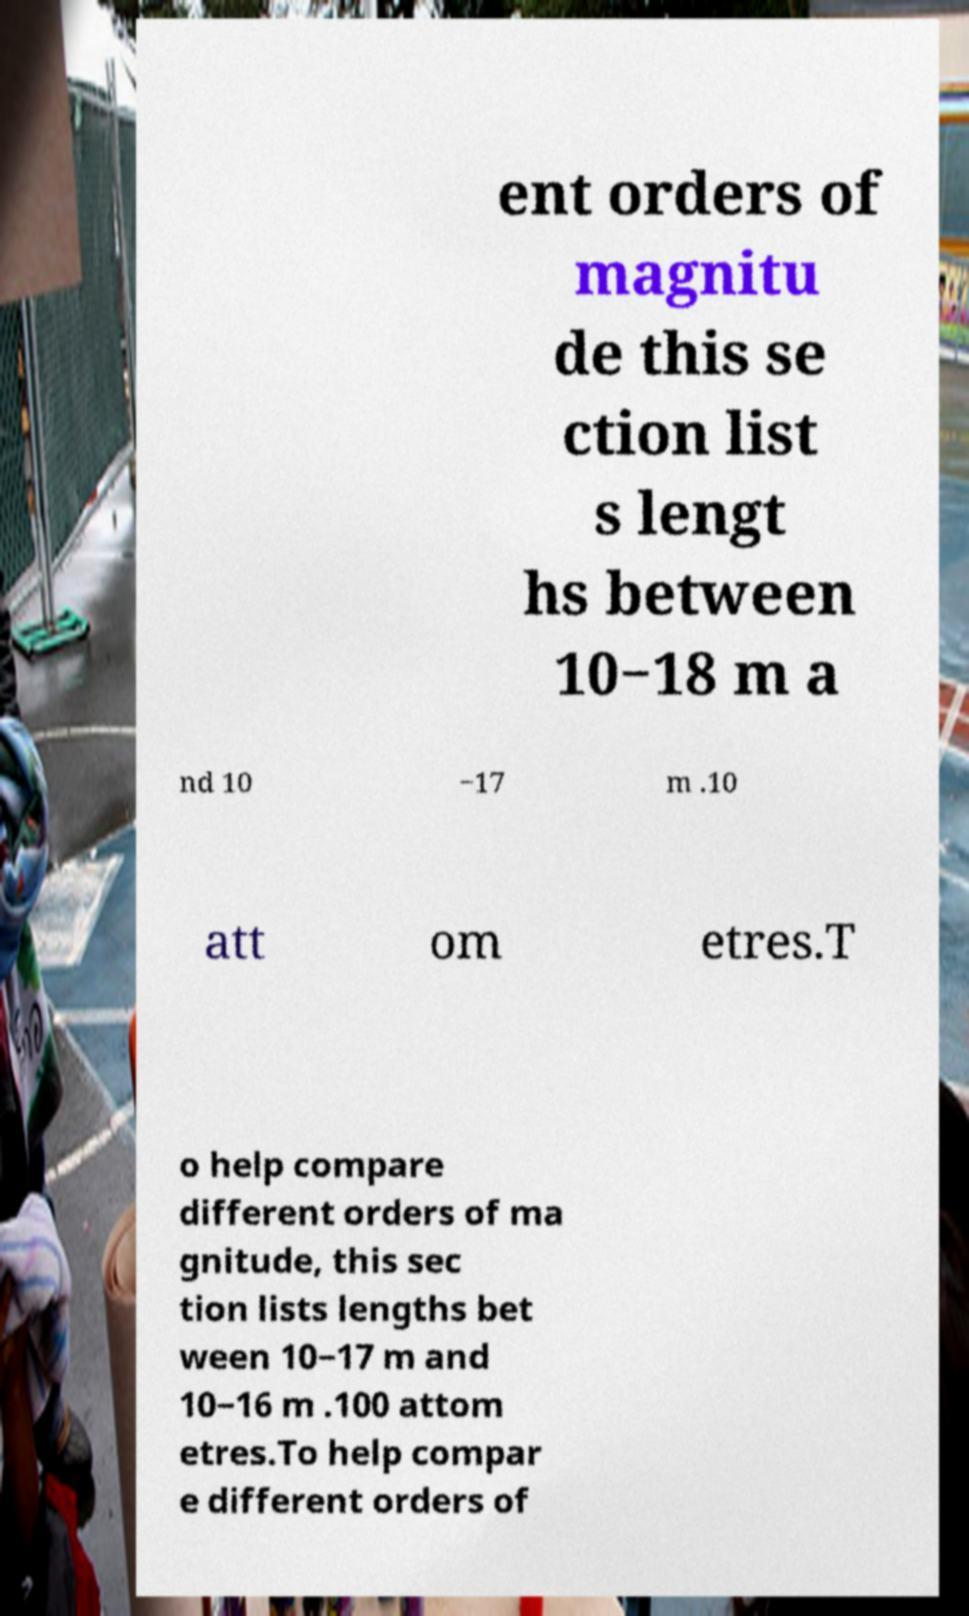Can you read and provide the text displayed in the image?This photo seems to have some interesting text. Can you extract and type it out for me? ent orders of magnitu de this se ction list s lengt hs between 10−18 m a nd 10 −17 m .10 att om etres.T o help compare different orders of ma gnitude, this sec tion lists lengths bet ween 10−17 m and 10−16 m .100 attom etres.To help compar e different orders of 